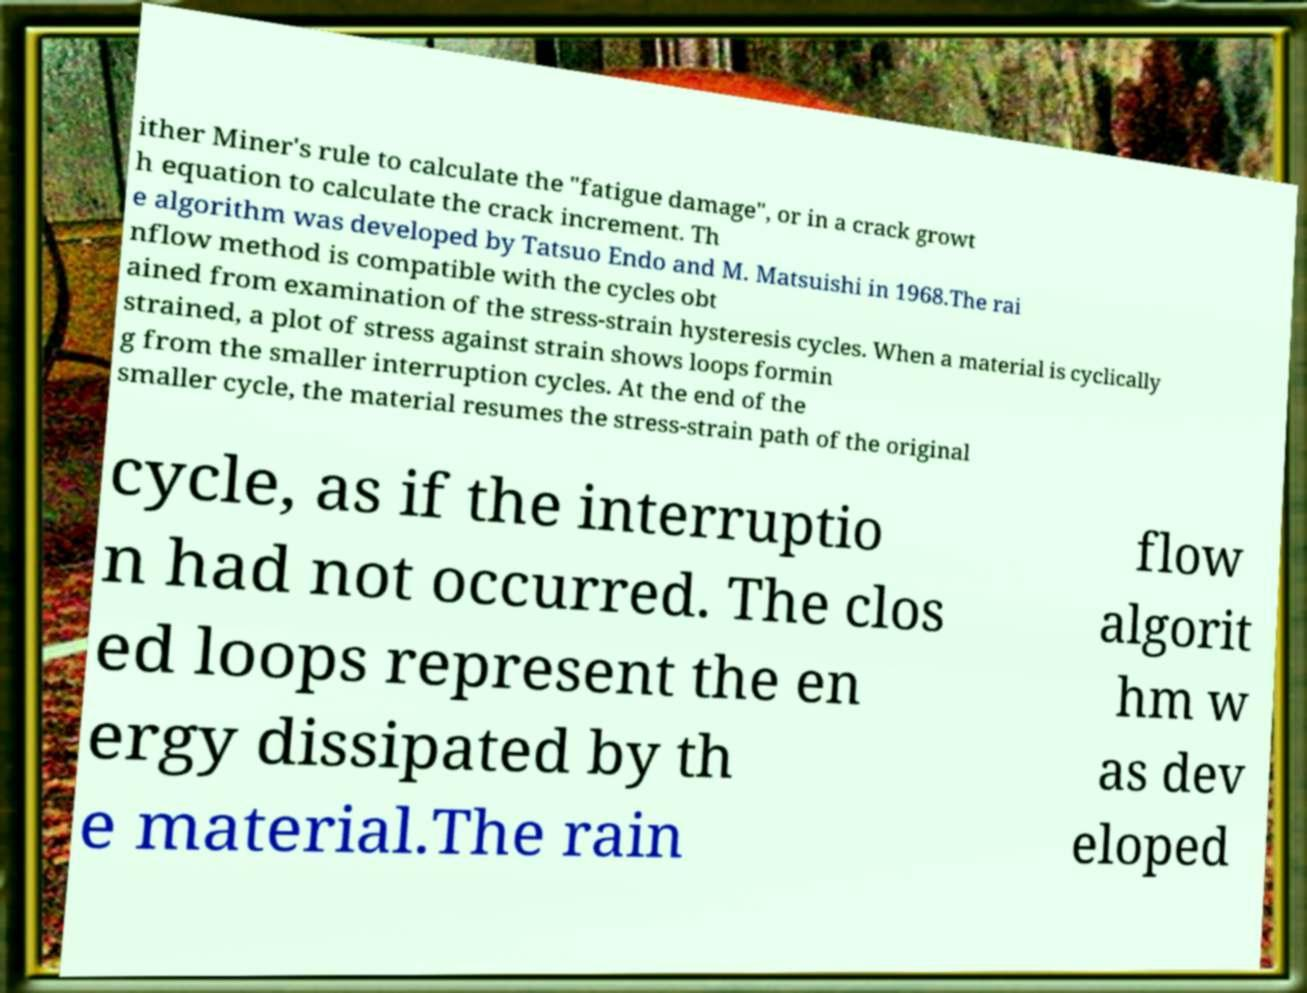Could you extract and type out the text from this image? ither Miner's rule to calculate the "fatigue damage", or in a crack growt h equation to calculate the crack increment. Th e algorithm was developed by Tatsuo Endo and M. Matsuishi in 1968.The rai nflow method is compatible with the cycles obt ained from examination of the stress-strain hysteresis cycles. When a material is cyclically strained, a plot of stress against strain shows loops formin g from the smaller interruption cycles. At the end of the smaller cycle, the material resumes the stress-strain path of the original cycle, as if the interruptio n had not occurred. The clos ed loops represent the en ergy dissipated by th e material.The rain flow algorit hm w as dev eloped 